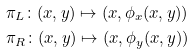Convert formula to latex. <formula><loc_0><loc_0><loc_500><loc_500>& \pi _ { L } \colon ( x , y ) \mapsto ( x , \phi _ { x } ( x , y ) ) \\ & \pi _ { R } \colon ( x , y ) \mapsto ( x , \phi _ { y } ( x , y ) )</formula> 